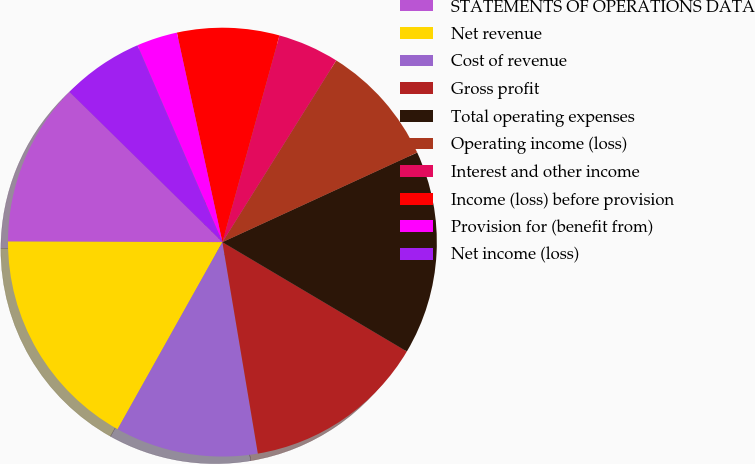<chart> <loc_0><loc_0><loc_500><loc_500><pie_chart><fcel>STATEMENTS OF OPERATIONS DATA<fcel>Net revenue<fcel>Cost of revenue<fcel>Gross profit<fcel>Total operating expenses<fcel>Operating income (loss)<fcel>Interest and other income<fcel>Income (loss) before provision<fcel>Provision for (benefit from)<fcel>Net income (loss)<nl><fcel>12.31%<fcel>16.92%<fcel>10.77%<fcel>13.84%<fcel>15.38%<fcel>9.23%<fcel>4.62%<fcel>7.69%<fcel>3.08%<fcel>6.16%<nl></chart> 